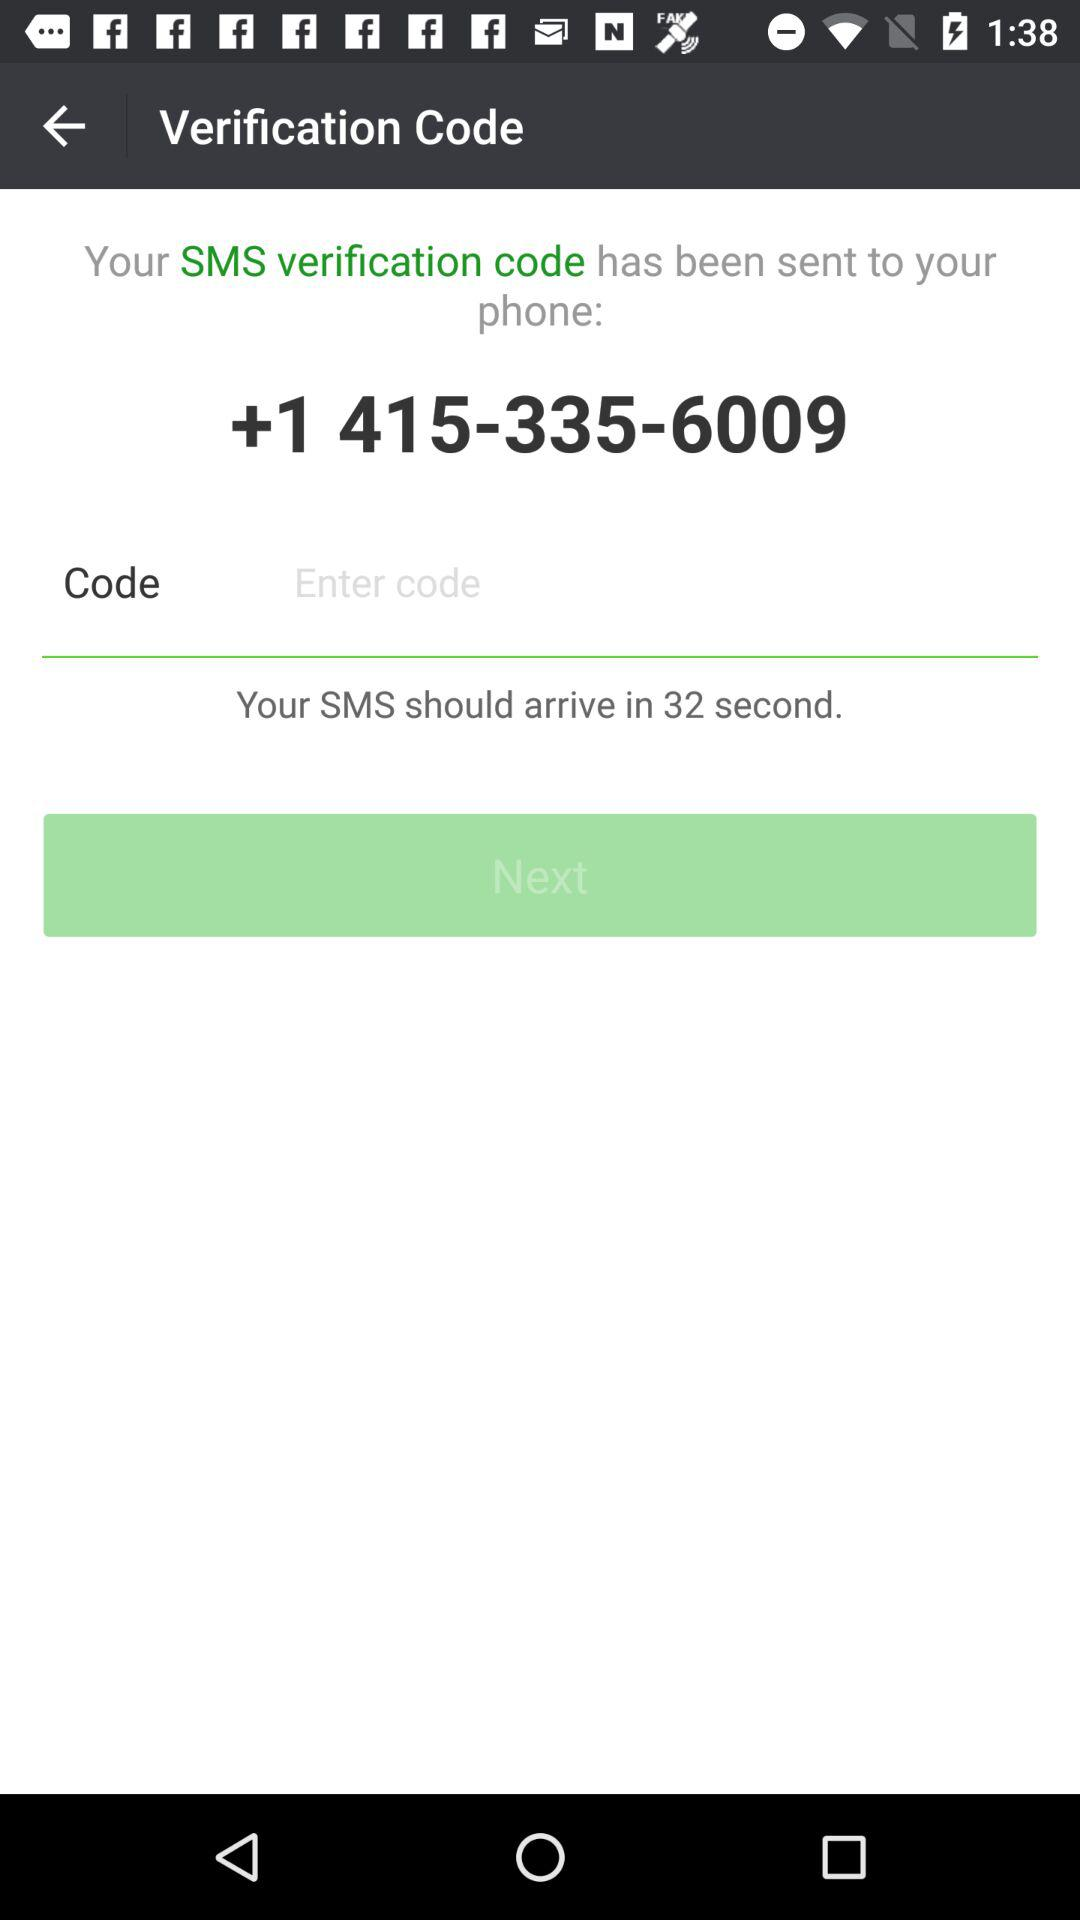What is the SMS arrival time duration? The SMS arrival time duration is 32 seconds. 